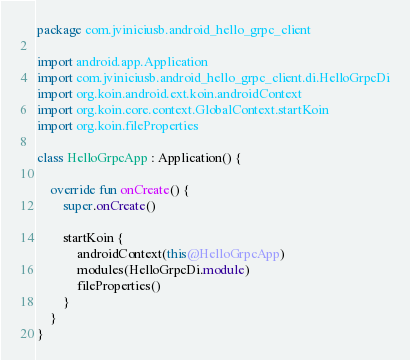<code> <loc_0><loc_0><loc_500><loc_500><_Kotlin_>package com.jviniciusb.android_hello_grpc_client

import android.app.Application
import com.jviniciusb.android_hello_grpc_client.di.HelloGrpcDi
import org.koin.android.ext.koin.androidContext
import org.koin.core.context.GlobalContext.startKoin
import org.koin.fileProperties

class HelloGrpcApp : Application() {

    override fun onCreate() {
        super.onCreate()

        startKoin {
            androidContext(this@HelloGrpcApp)
            modules(HelloGrpcDi.module)
            fileProperties()
        }
    }
}</code> 